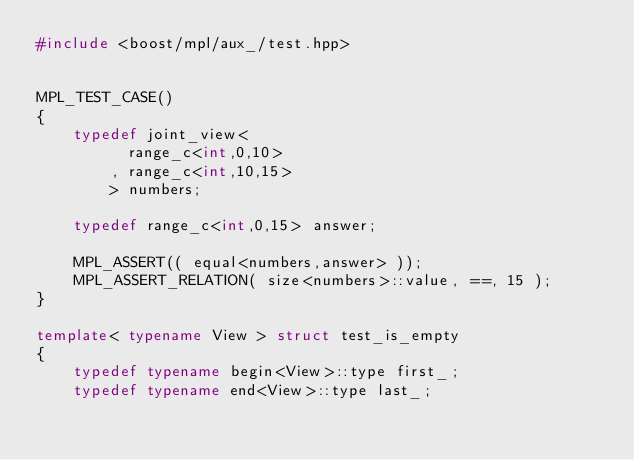<code> <loc_0><loc_0><loc_500><loc_500><_C++_>#include <boost/mpl/aux_/test.hpp>


MPL_TEST_CASE()
{
    typedef joint_view<
          range_c<int,0,10>
        , range_c<int,10,15>
        > numbers;

    typedef range_c<int,0,15> answer;

    MPL_ASSERT(( equal<numbers,answer> ));
    MPL_ASSERT_RELATION( size<numbers>::value, ==, 15 );
}

template< typename View > struct test_is_empty
{
    typedef typename begin<View>::type first_;
    typedef typename end<View>::type last_;
    </code> 